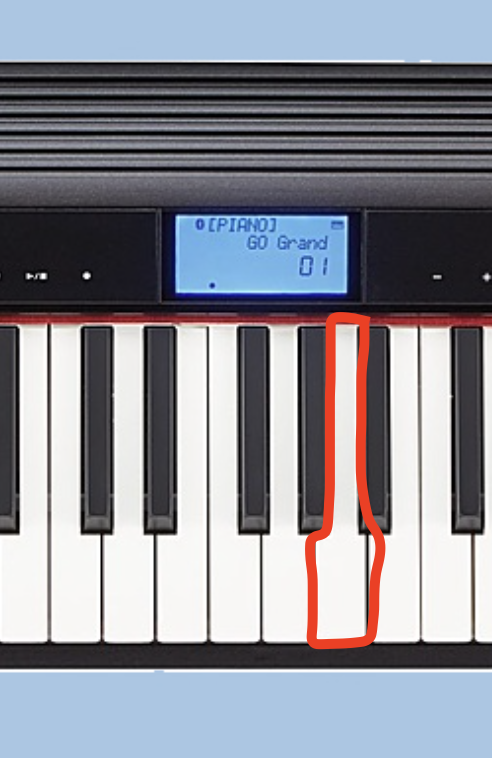What key is this? Based on the image, the red-highlighted key on the piano keyboard appears to be the C major key or the note C. The display on the keyboard shows "C[PIANO] Ch Grand 01", which suggests that the highlighted key represents the root note C for the selected piano/grand piano sound. 